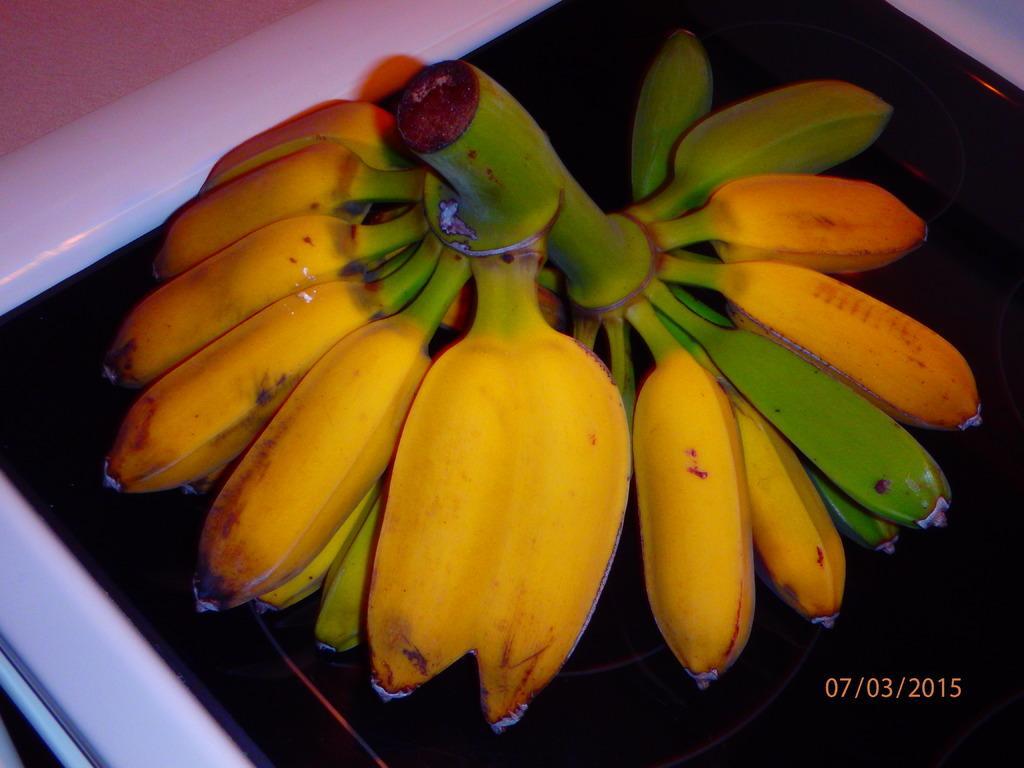How would you summarize this image in a sentence or two? In this image there are bananas on the table. 